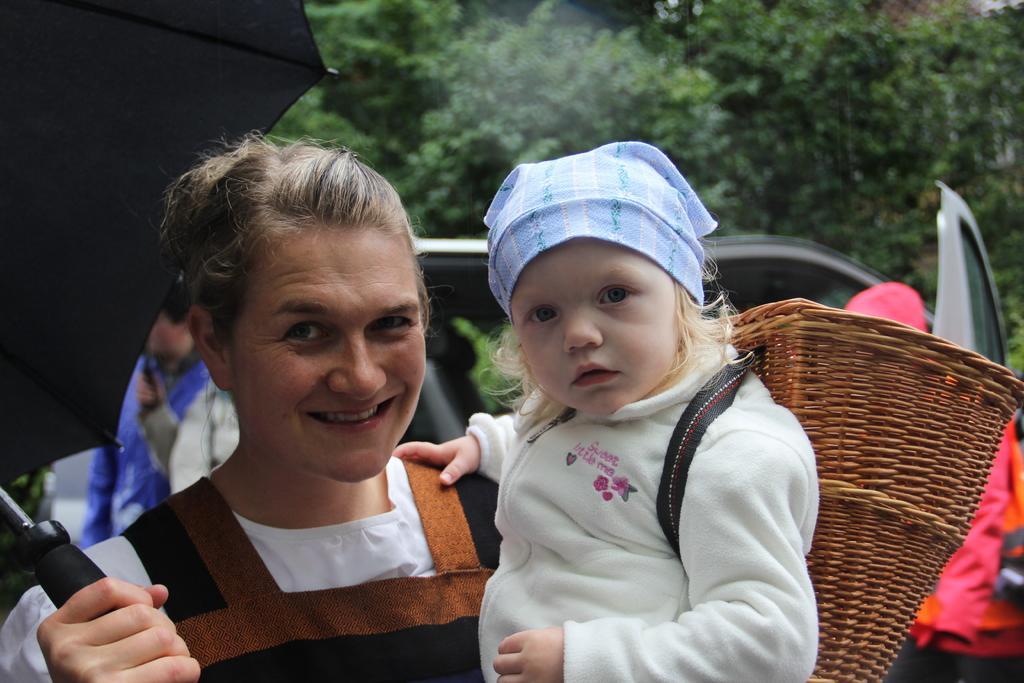Could you give a brief overview of what you see in this image? In the foreground I can see a woman is holding a baby and an umbrella in hand. In the background I can see a car and trees. This image is taken during a rainy day on the road. 